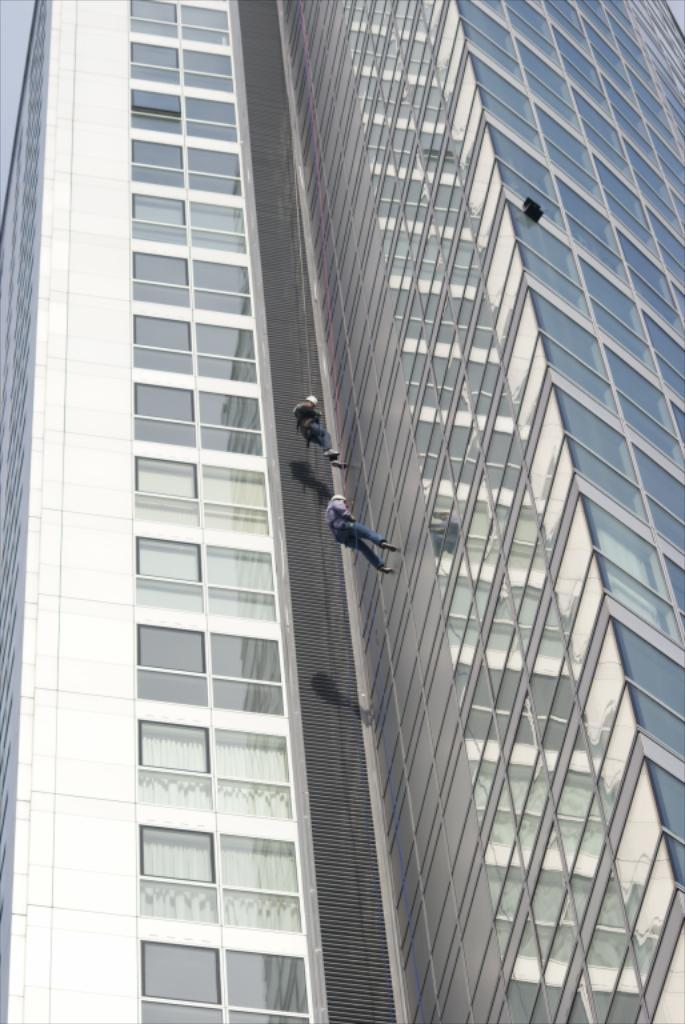What type of building is visible in the image? There is a building with glass in the image. What are the two persons doing in the image? The two persons are hanging with ropes in the image. What type of comfort can be seen in the image? There is no specific comfort visible in the image; it features a building with glass and two persons hanging with ropes. What musical instrument is being played in the image? There is no musical instrument present in the image. 